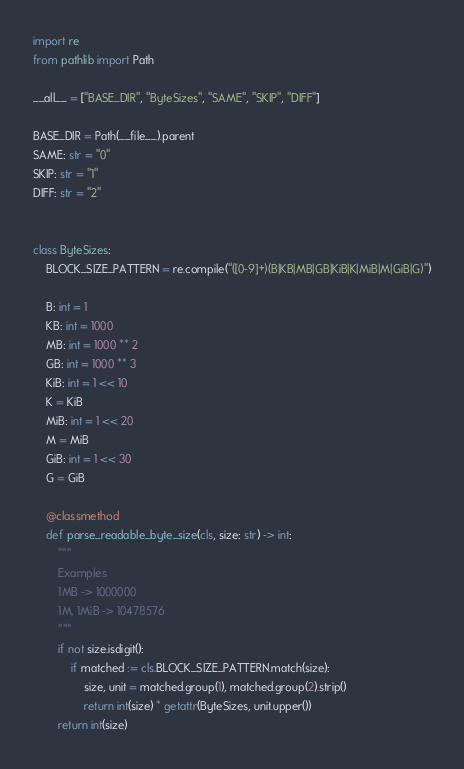Convert code to text. <code><loc_0><loc_0><loc_500><loc_500><_Python_>import re
from pathlib import Path

__all__ = ["BASE_DIR", "ByteSizes", "SAME", "SKIP", "DIFF"]

BASE_DIR = Path(__file__).parent
SAME: str = "0"
SKIP: str = "1"
DIFF: str = "2"


class ByteSizes:
    BLOCK_SIZE_PATTERN = re.compile("([0-9]+)(B|KB|MB|GB|KiB|K|MiB|M|GiB|G)")

    B: int = 1
    KB: int = 1000
    MB: int = 1000 ** 2
    GB: int = 1000 ** 3
    KiB: int = 1 << 10
    K = KiB
    MiB: int = 1 << 20
    M = MiB
    GiB: int = 1 << 30
    G = GiB

    @classmethod
    def parse_readable_byte_size(cls, size: str) -> int:
        """
        Examples
        1MB -> 1000000
        1M, 1MiB -> 10478576
        """
        if not size.isdigit():
            if matched := cls.BLOCK_SIZE_PATTERN.match(size):
                size, unit = matched.group(1), matched.group(2).strip()
                return int(size) * getattr(ByteSizes, unit.upper())
        return int(size)
</code> 